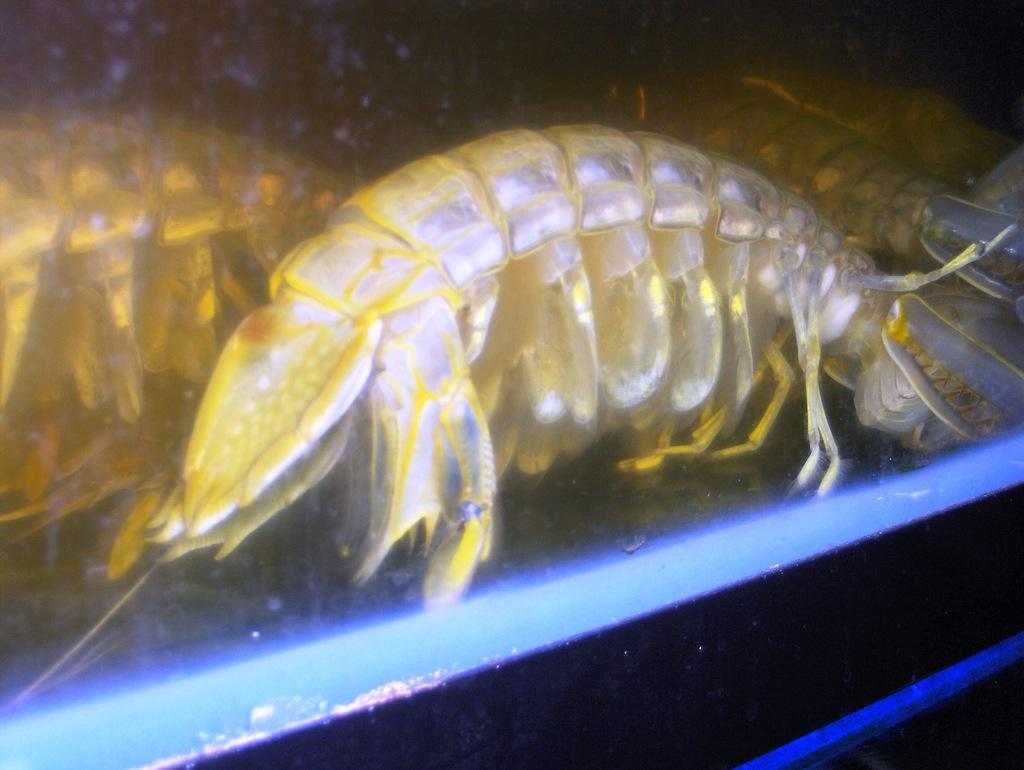What type of seafood can be seen in the image? There are shrimps in the image. Where are the shrimps located? The shrimps are in a water body. How does the baby shrimp hope to grow up in the image? There is no baby shrimp present in the image, and therefore no such growth or hope can be observed. 